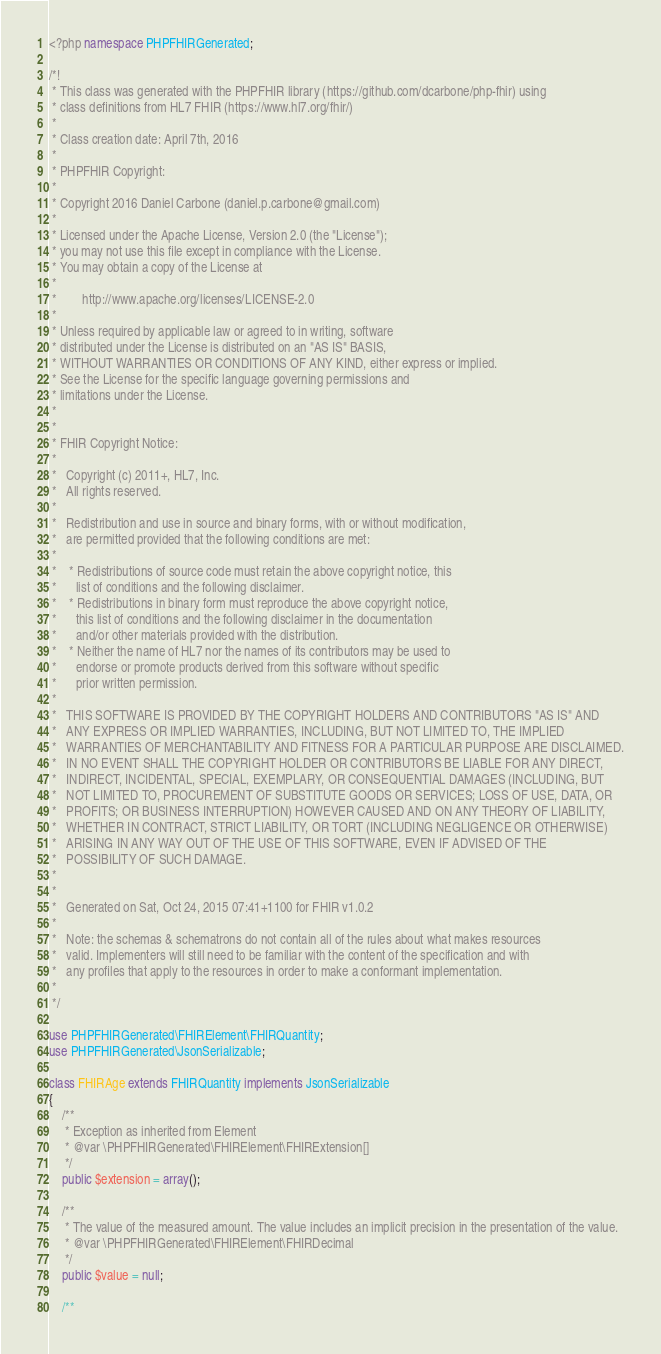<code> <loc_0><loc_0><loc_500><loc_500><_PHP_><?php namespace PHPFHIRGenerated;

/*!
 * This class was generated with the PHPFHIR library (https://github.com/dcarbone/php-fhir) using
 * class definitions from HL7 FHIR (https://www.hl7.org/fhir/)
 * 
 * Class creation date: April 7th, 2016
 * 
 * PHPFHIR Copyright:
 * 
 * Copyright 2016 Daniel Carbone (daniel.p.carbone@gmail.com)
 * 
 * Licensed under the Apache License, Version 2.0 (the "License");
 * you may not use this file except in compliance with the License.
 * You may obtain a copy of the License at
 * 
 *        http://www.apache.org/licenses/LICENSE-2.0
 * 
 * Unless required by applicable law or agreed to in writing, software
 * distributed under the License is distributed on an "AS IS" BASIS,
 * WITHOUT WARRANTIES OR CONDITIONS OF ANY KIND, either express or implied.
 * See the License for the specific language governing permissions and
 * limitations under the License.
 * 
 *
 * FHIR Copyright Notice:
 *
 *   Copyright (c) 2011+, HL7, Inc.
 *   All rights reserved.
 * 
 *   Redistribution and use in source and binary forms, with or without modification,
 *   are permitted provided that the following conditions are met:
 * 
 *    * Redistributions of source code must retain the above copyright notice, this
 *      list of conditions and the following disclaimer.
 *    * Redistributions in binary form must reproduce the above copyright notice,
 *      this list of conditions and the following disclaimer in the documentation
 *      and/or other materials provided with the distribution.
 *    * Neither the name of HL7 nor the names of its contributors may be used to
 *      endorse or promote products derived from this software without specific
 *      prior written permission.
 * 
 *   THIS SOFTWARE IS PROVIDED BY THE COPYRIGHT HOLDERS AND CONTRIBUTORS "AS IS" AND
 *   ANY EXPRESS OR IMPLIED WARRANTIES, INCLUDING, BUT NOT LIMITED TO, THE IMPLIED
 *   WARRANTIES OF MERCHANTABILITY AND FITNESS FOR A PARTICULAR PURPOSE ARE DISCLAIMED.
 *   IN NO EVENT SHALL THE COPYRIGHT HOLDER OR CONTRIBUTORS BE LIABLE FOR ANY DIRECT,
 *   INDIRECT, INCIDENTAL, SPECIAL, EXEMPLARY, OR CONSEQUENTIAL DAMAGES (INCLUDING, BUT
 *   NOT LIMITED TO, PROCUREMENT OF SUBSTITUTE GOODS OR SERVICES; LOSS OF USE, DATA, OR
 *   PROFITS; OR BUSINESS INTERRUPTION) HOWEVER CAUSED AND ON ANY THEORY OF LIABILITY,
 *   WHETHER IN CONTRACT, STRICT LIABILITY, OR TORT (INCLUDING NEGLIGENCE OR OTHERWISE)
 *   ARISING IN ANY WAY OUT OF THE USE OF THIS SOFTWARE, EVEN IF ADVISED OF THE
 *   POSSIBILITY OF SUCH DAMAGE.
 * 
 * 
 *   Generated on Sat, Oct 24, 2015 07:41+1100 for FHIR v1.0.2
 * 
 *   Note: the schemas & schematrons do not contain all of the rules about what makes resources
 *   valid. Implementers will still need to be familiar with the content of the specification and with
 *   any profiles that apply to the resources in order to make a conformant implementation.
 * 
 */

use PHPFHIRGenerated\FHIRElement\FHIRQuantity;
use PHPFHIRGenerated\JsonSerializable;

class FHIRAge extends FHIRQuantity implements JsonSerializable
{
    /**
     * Exception as inherited from Element
     * @var \PHPFHIRGenerated\FHIRElement\FHIRExtension[]
     */
    public $extension = array();

    /**
     * The value of the measured amount. The value includes an implicit precision in the presentation of the value.
     * @var \PHPFHIRGenerated\FHIRElement\FHIRDecimal
     */
    public $value = null;

    /**</code> 